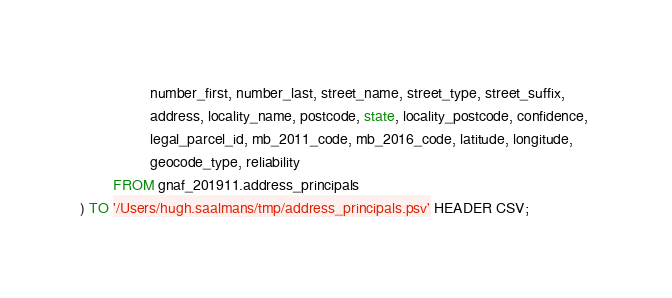Convert code to text. <code><loc_0><loc_0><loc_500><loc_500><_SQL_>				 number_first, number_last, street_name, street_type, street_suffix, 
				 address, locality_name, postcode, state, locality_postcode, confidence, 
				 legal_parcel_id, mb_2011_code, mb_2016_code, latitude, longitude, 
				 geocode_type, reliability
		FROM gnaf_201911.address_principals
) TO '/Users/hugh.saalmans/tmp/address_principals.psv' HEADER CSV;
</code> 